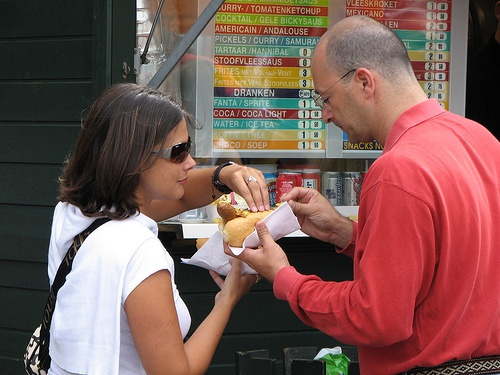Describe the objects in this image and their specific colors. I can see people in black, brown, and salmon tones, people in black, lavender, salmon, and gray tones, handbag in black, lightgray, gray, and darkgray tones, hot dog in black, tan, brown, and lightgray tones, and sandwich in black, lavender, darkgray, and gray tones in this image. 